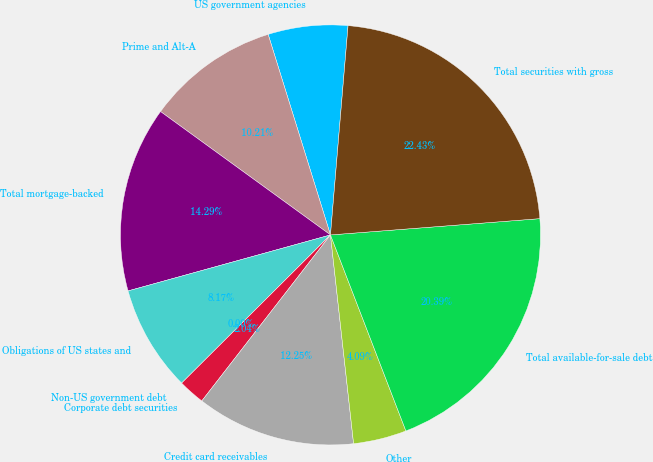Convert chart to OTSL. <chart><loc_0><loc_0><loc_500><loc_500><pie_chart><fcel>US government agencies<fcel>Prime and Alt-A<fcel>Total mortgage-backed<fcel>Obligations of US states and<fcel>Non-US government debt<fcel>Corporate debt securities<fcel>Credit card receivables<fcel>Other<fcel>Total available-for-sale debt<fcel>Total securities with gross<nl><fcel>6.13%<fcel>10.21%<fcel>14.29%<fcel>8.17%<fcel>0.0%<fcel>2.04%<fcel>12.25%<fcel>4.09%<fcel>20.39%<fcel>22.43%<nl></chart> 